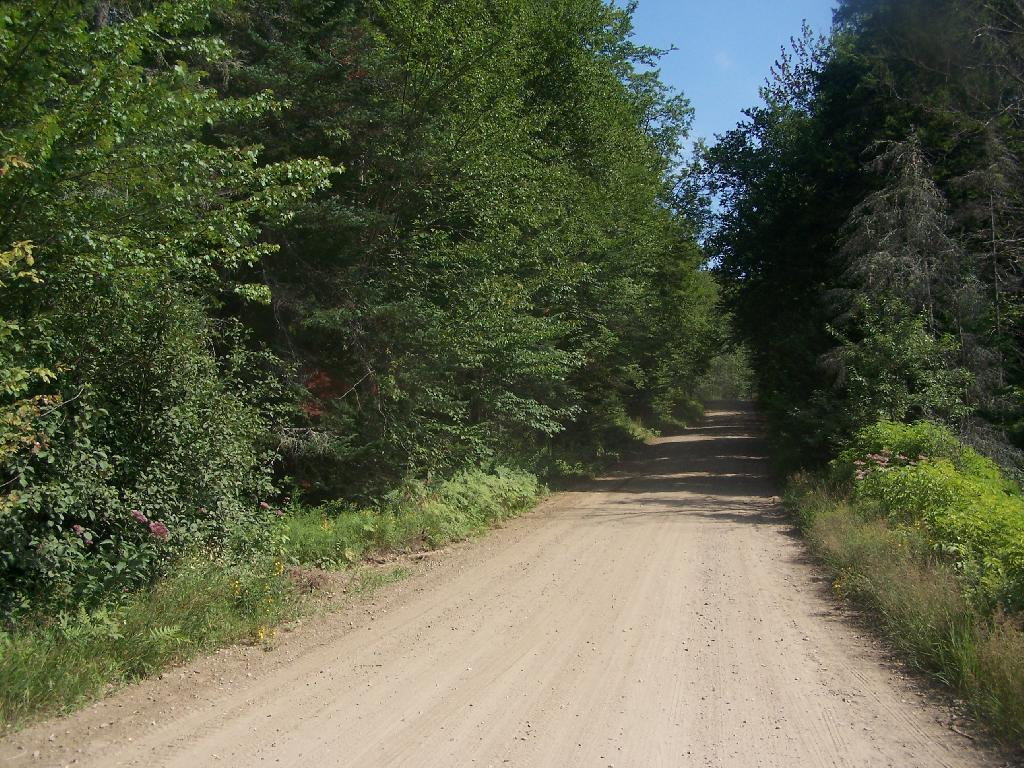What is visible in the center of the image? The sky is visible in the center of the image. What type of vegetation can be seen in the image? There are trees and plants in the image. What is the ground surface like in the image? Grass is visible in the image. What type of man-made structure is present in the image? There is a road in the image. What type of bait is being used to catch fish in the image? There is no mention of fish or bait in the image, as it primarily features natural elements like the sky, trees, plants, grass, and a road. 